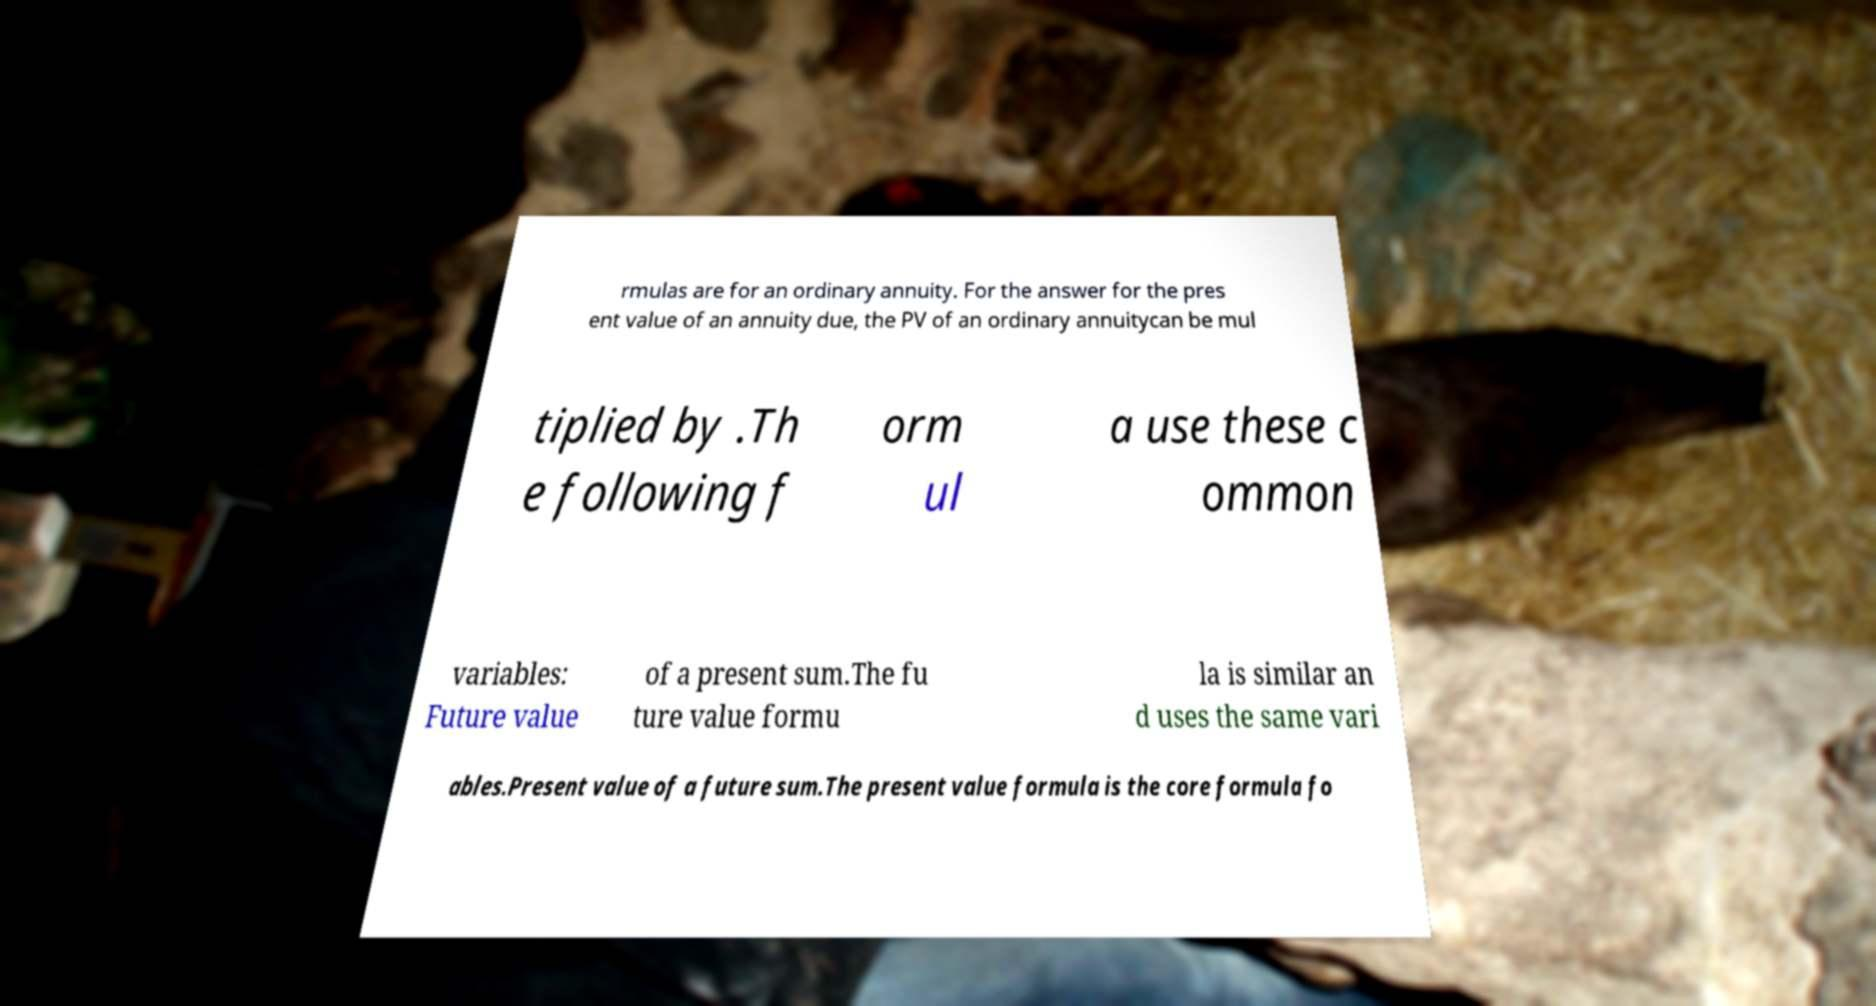Could you assist in decoding the text presented in this image and type it out clearly? rmulas are for an ordinary annuity. For the answer for the pres ent value of an annuity due, the PV of an ordinary annuitycan be mul tiplied by .Th e following f orm ul a use these c ommon variables: Future value of a present sum.The fu ture value formu la is similar an d uses the same vari ables.Present value of a future sum.The present value formula is the core formula fo 